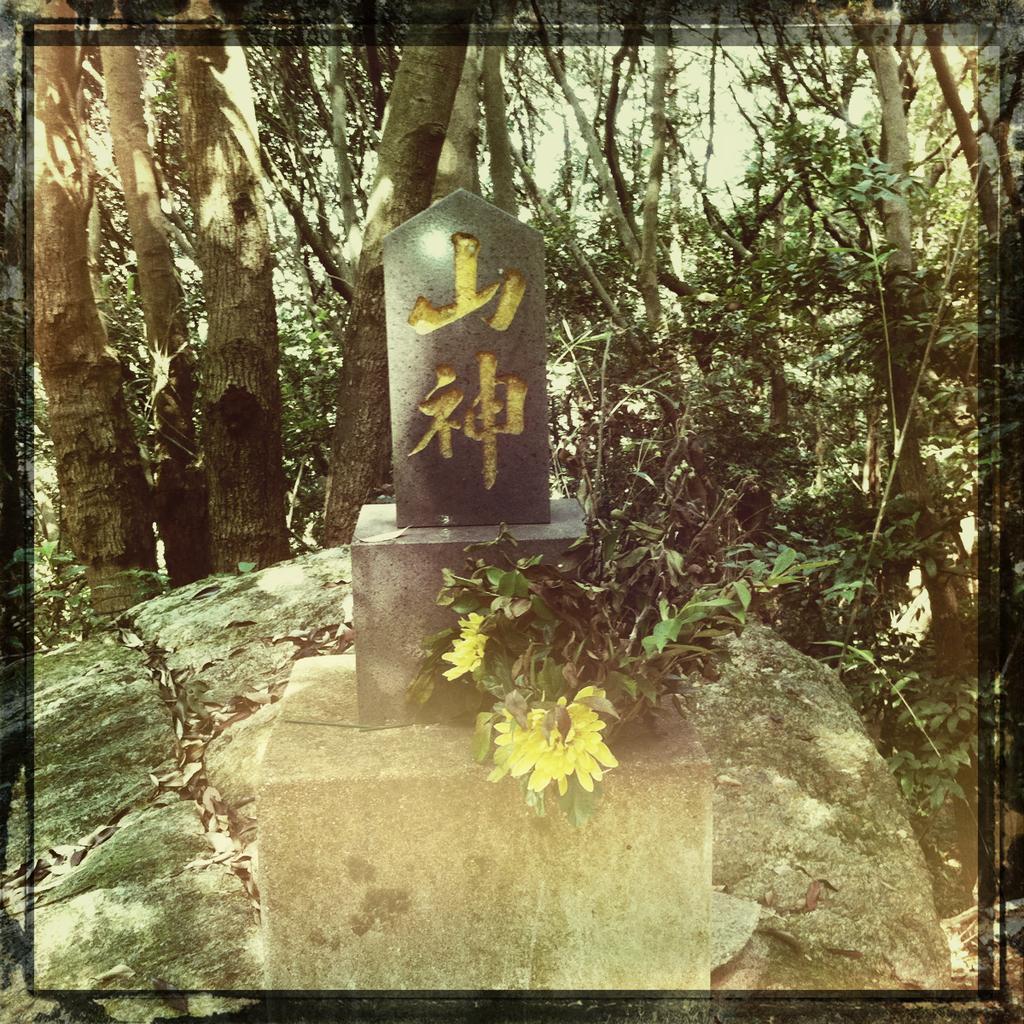Describe this image in one or two sentences. This is an edited picture. In this picture we can see trees, dried leaves, stones, branches, wall and rocks. 